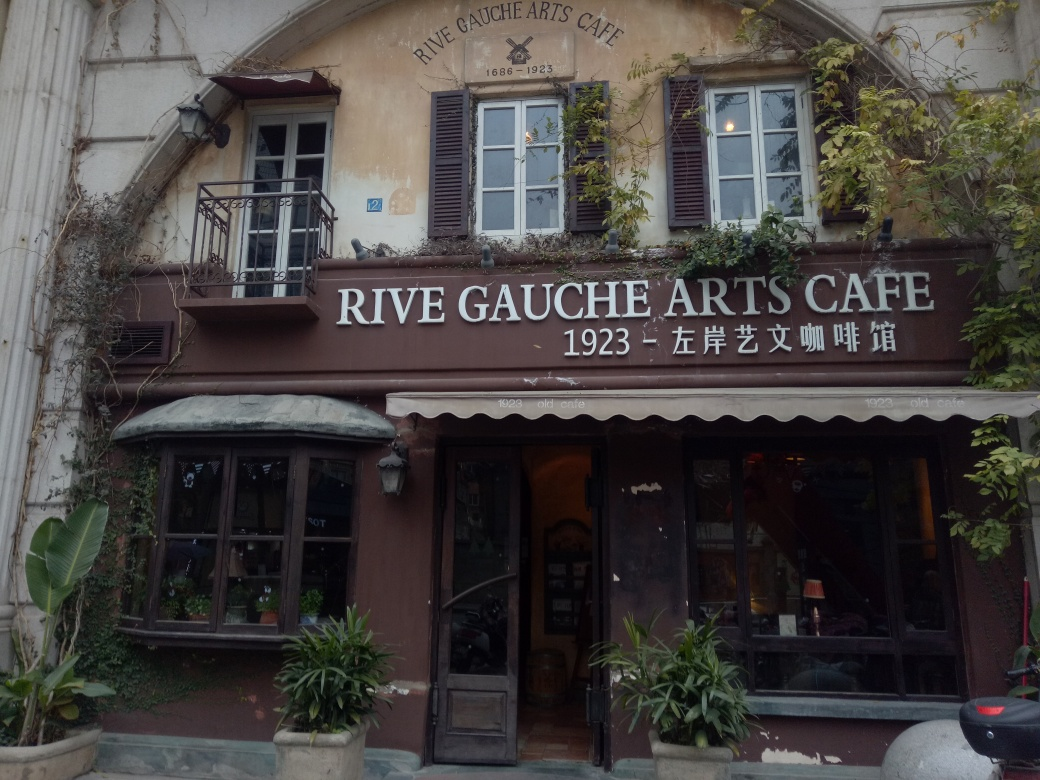Can you describe the mood or atmosphere that this café's exterior evokes? The café exudes a sense of cozy nostalgia and artful elegance. The worn façade, lush foliage, and classic window frames create a welcoming and intimate atmosphere, inviting passersby to step in and experience a slice of history over a cup of coffee. What elements contribute to the historical feel of the café? The historical feel of the café is conveyed through details like the traditional script on the sign, the date '1923' suggesting a rich backstory, as well as the weathered texture of the walls and windows, all hinting at a place that has witnessed decades of cultural shifts and gatherings. 